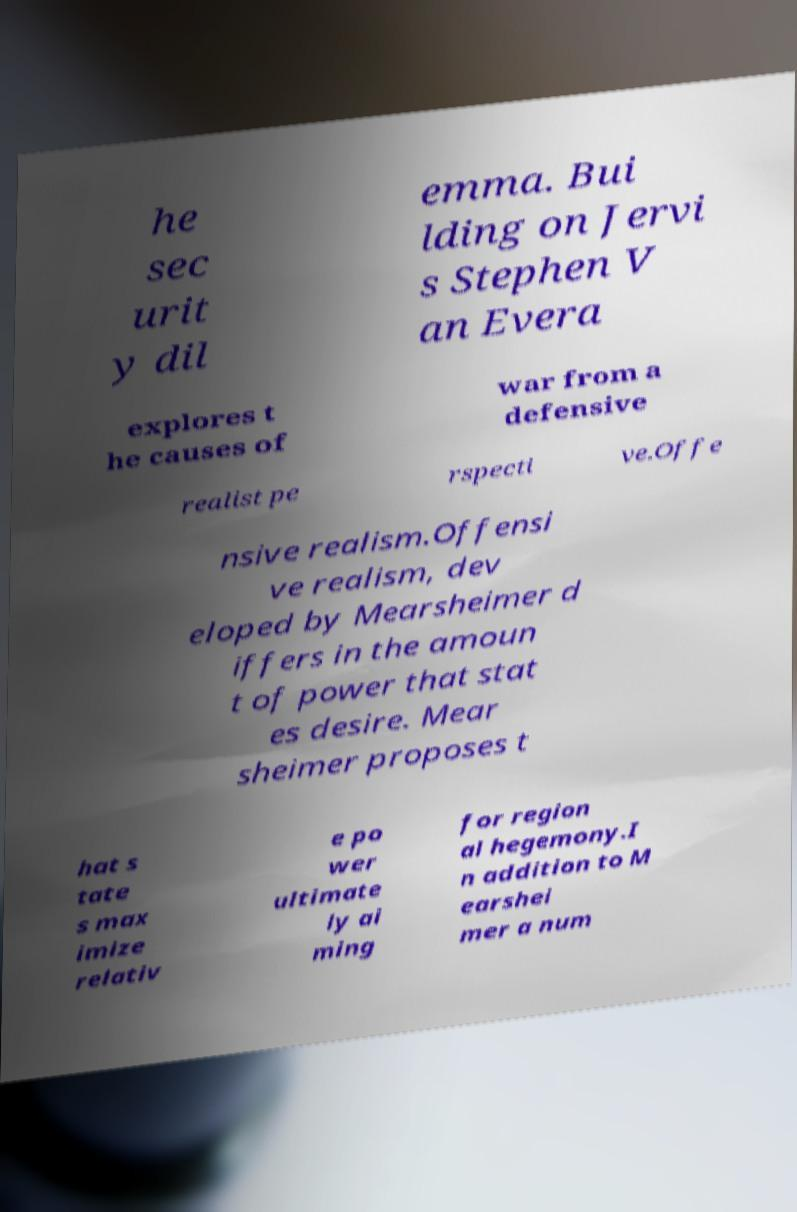Can you accurately transcribe the text from the provided image for me? he sec urit y dil emma. Bui lding on Jervi s Stephen V an Evera explores t he causes of war from a defensive realist pe rspecti ve.Offe nsive realism.Offensi ve realism, dev eloped by Mearsheimer d iffers in the amoun t of power that stat es desire. Mear sheimer proposes t hat s tate s max imize relativ e po wer ultimate ly ai ming for region al hegemony.I n addition to M earshei mer a num 